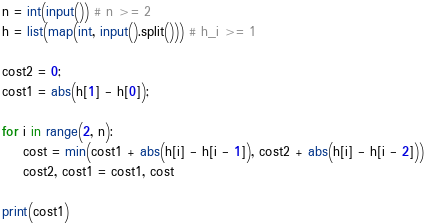<code> <loc_0><loc_0><loc_500><loc_500><_Python_>n = int(input()) # n >= 2
h = list(map(int, input().split())) # h_i >= 1

cost2 = 0;
cost1 = abs(h[1] - h[0]);

for i in range(2, n):
    cost = min(cost1 + abs(h[i] - h[i - 1]), cost2 + abs(h[i] - h[i - 2]))
    cost2, cost1 = cost1, cost

print(cost1)</code> 